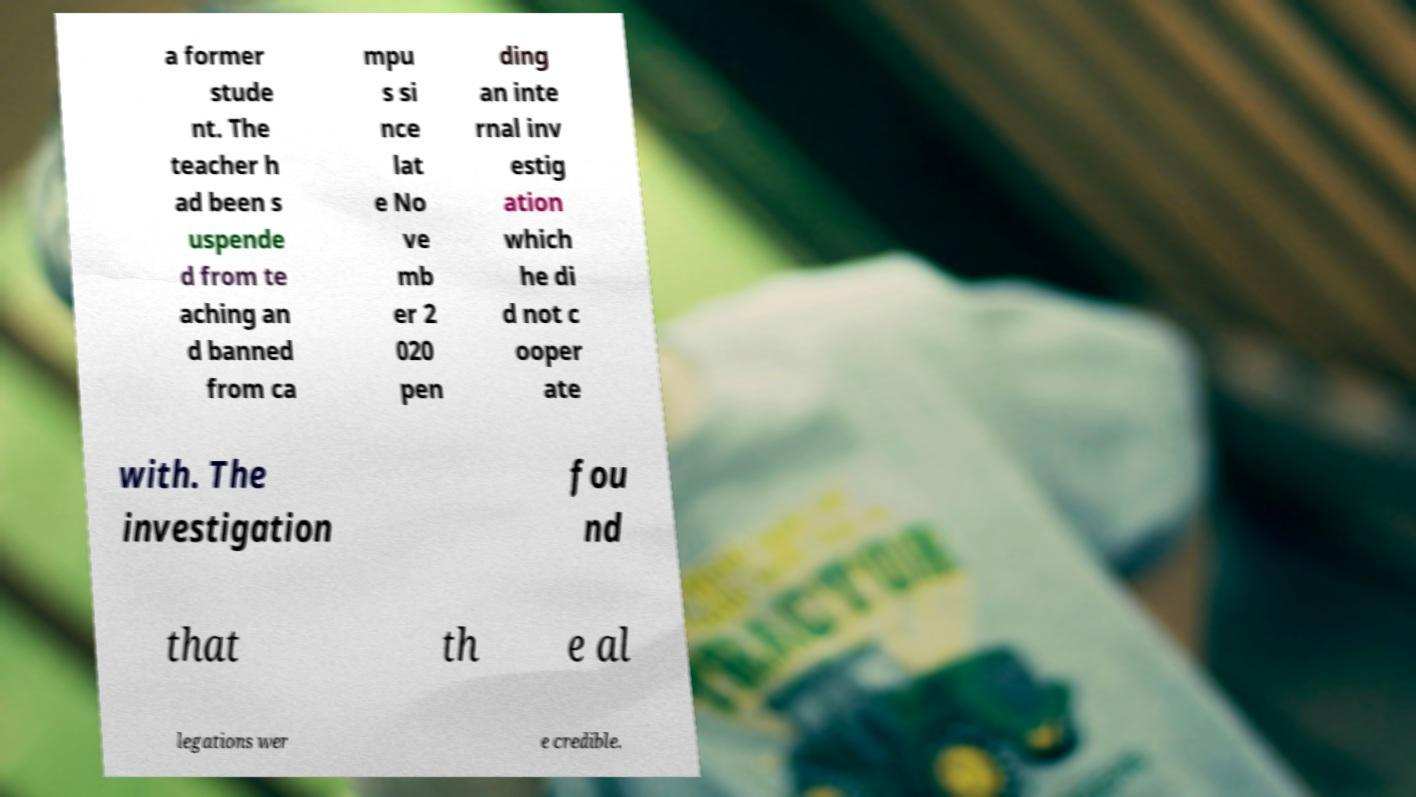There's text embedded in this image that I need extracted. Can you transcribe it verbatim? a former stude nt. The teacher h ad been s uspende d from te aching an d banned from ca mpu s si nce lat e No ve mb er 2 020 pen ding an inte rnal inv estig ation which he di d not c ooper ate with. The investigation fou nd that th e al legations wer e credible. 